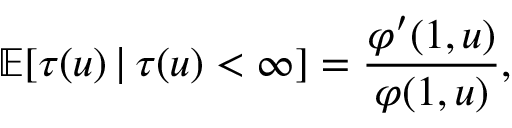Convert formula to latex. <formula><loc_0><loc_0><loc_500><loc_500>\mathbb { E } [ \tau ( u ) \, | \, \tau ( u ) < \infty ] = \frac { \varphi ^ { \prime } ( 1 , u ) } { \varphi ( 1 , u ) } ,</formula> 